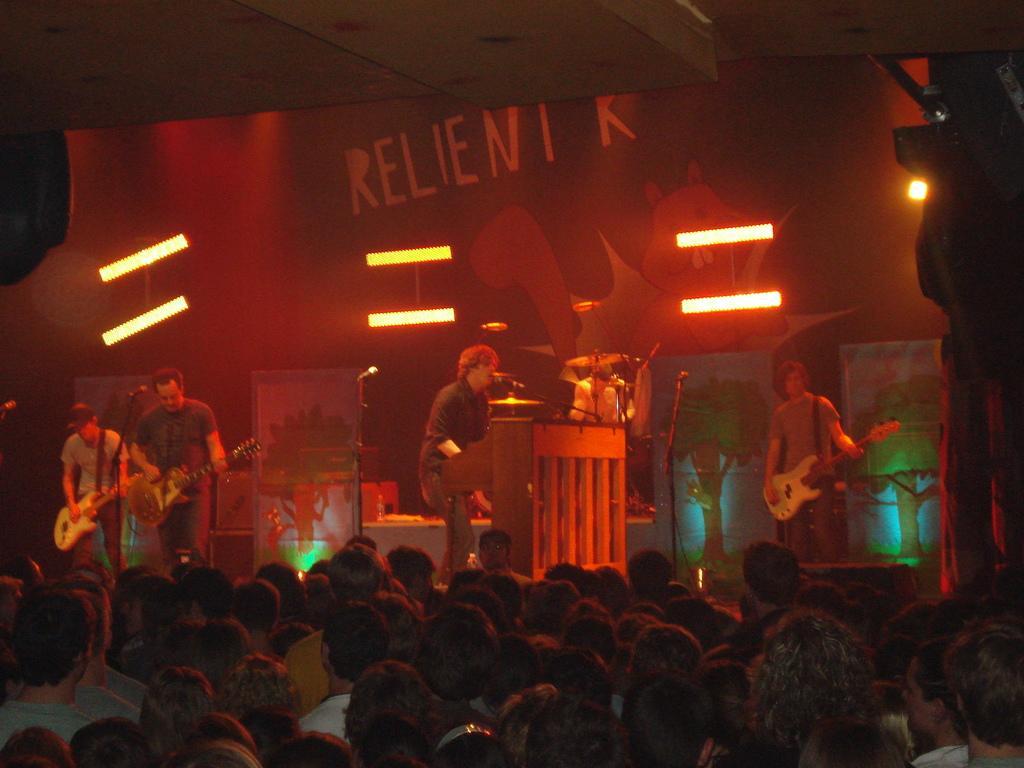How would you summarize this image in a sentence or two? In this image, we can see people performing on the stage using guitar and in the background, there is a crowd. 